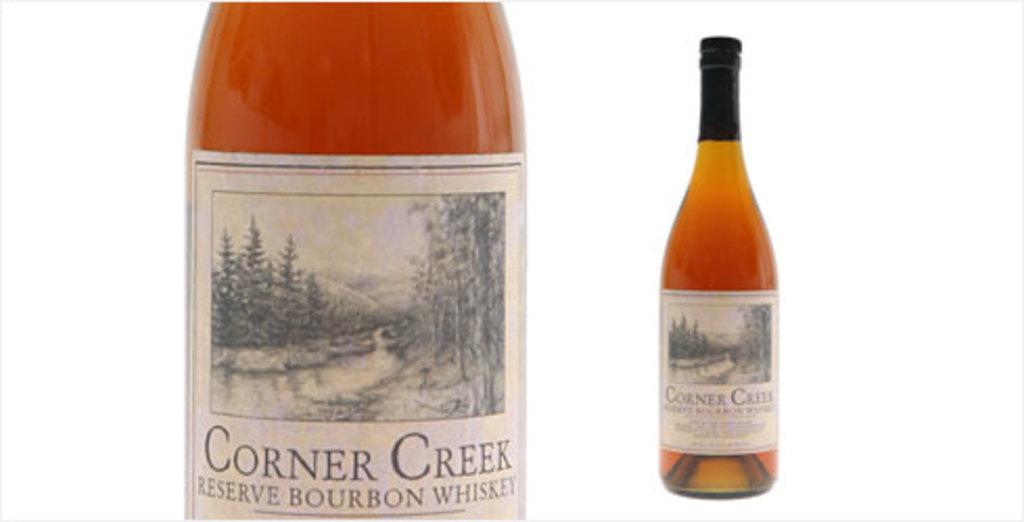What particular type of whiskey is this?
Offer a terse response. Bourbon. What brand is this?
Offer a terse response. Corner creek. 